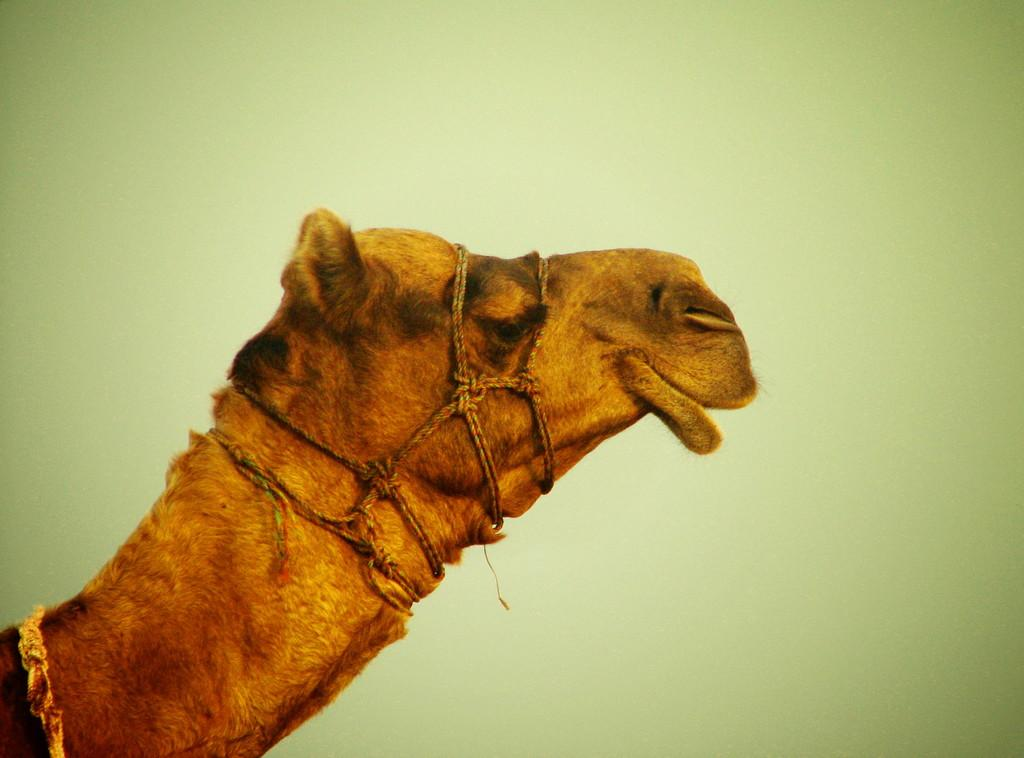What animal is the main subject of the image? There is a camel in the image. Can you describe the color of the camel? The camel is brown and black in color. What is attached to the camel in the image? There are ropes tied to the camel. What can be seen in the background of the image? The background of the image is green. How many donkeys are visible in the image? There are no donkeys present in the image; it features a camel. What type of quartz can be seen in the image? There is no quartz present in the image. 